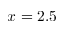<formula> <loc_0><loc_0><loc_500><loc_500>x = 2 . 5</formula> 